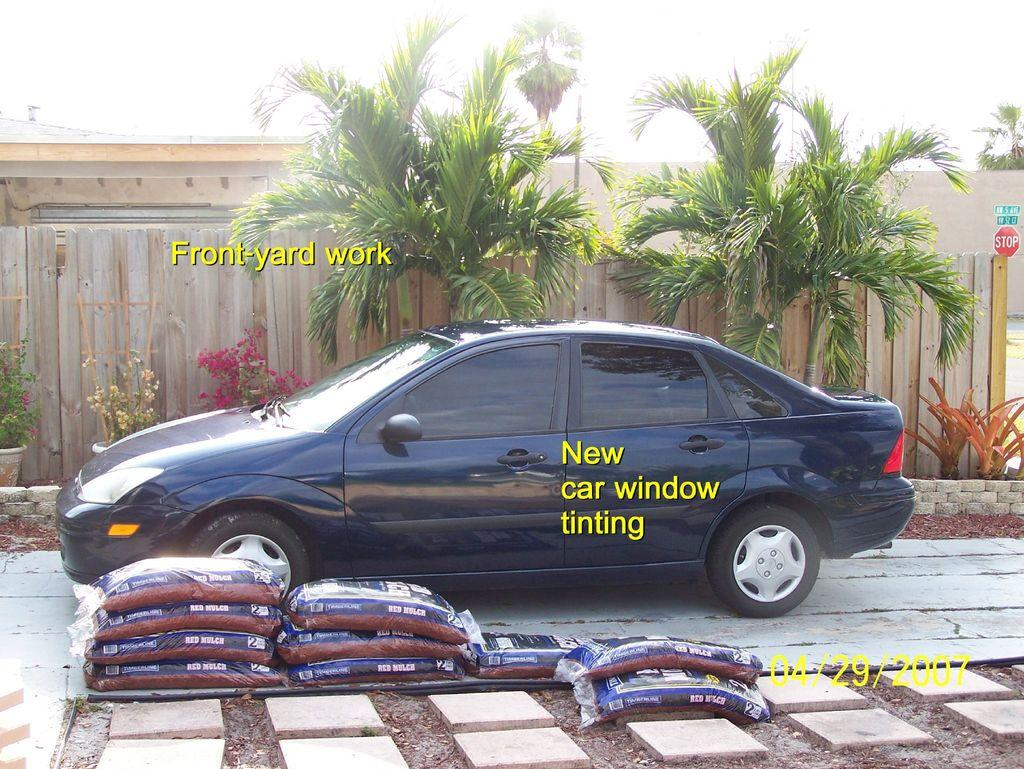<image>
Relay a brief, clear account of the picture shown. Several bags of red mulch are stacked next to a blue car. 